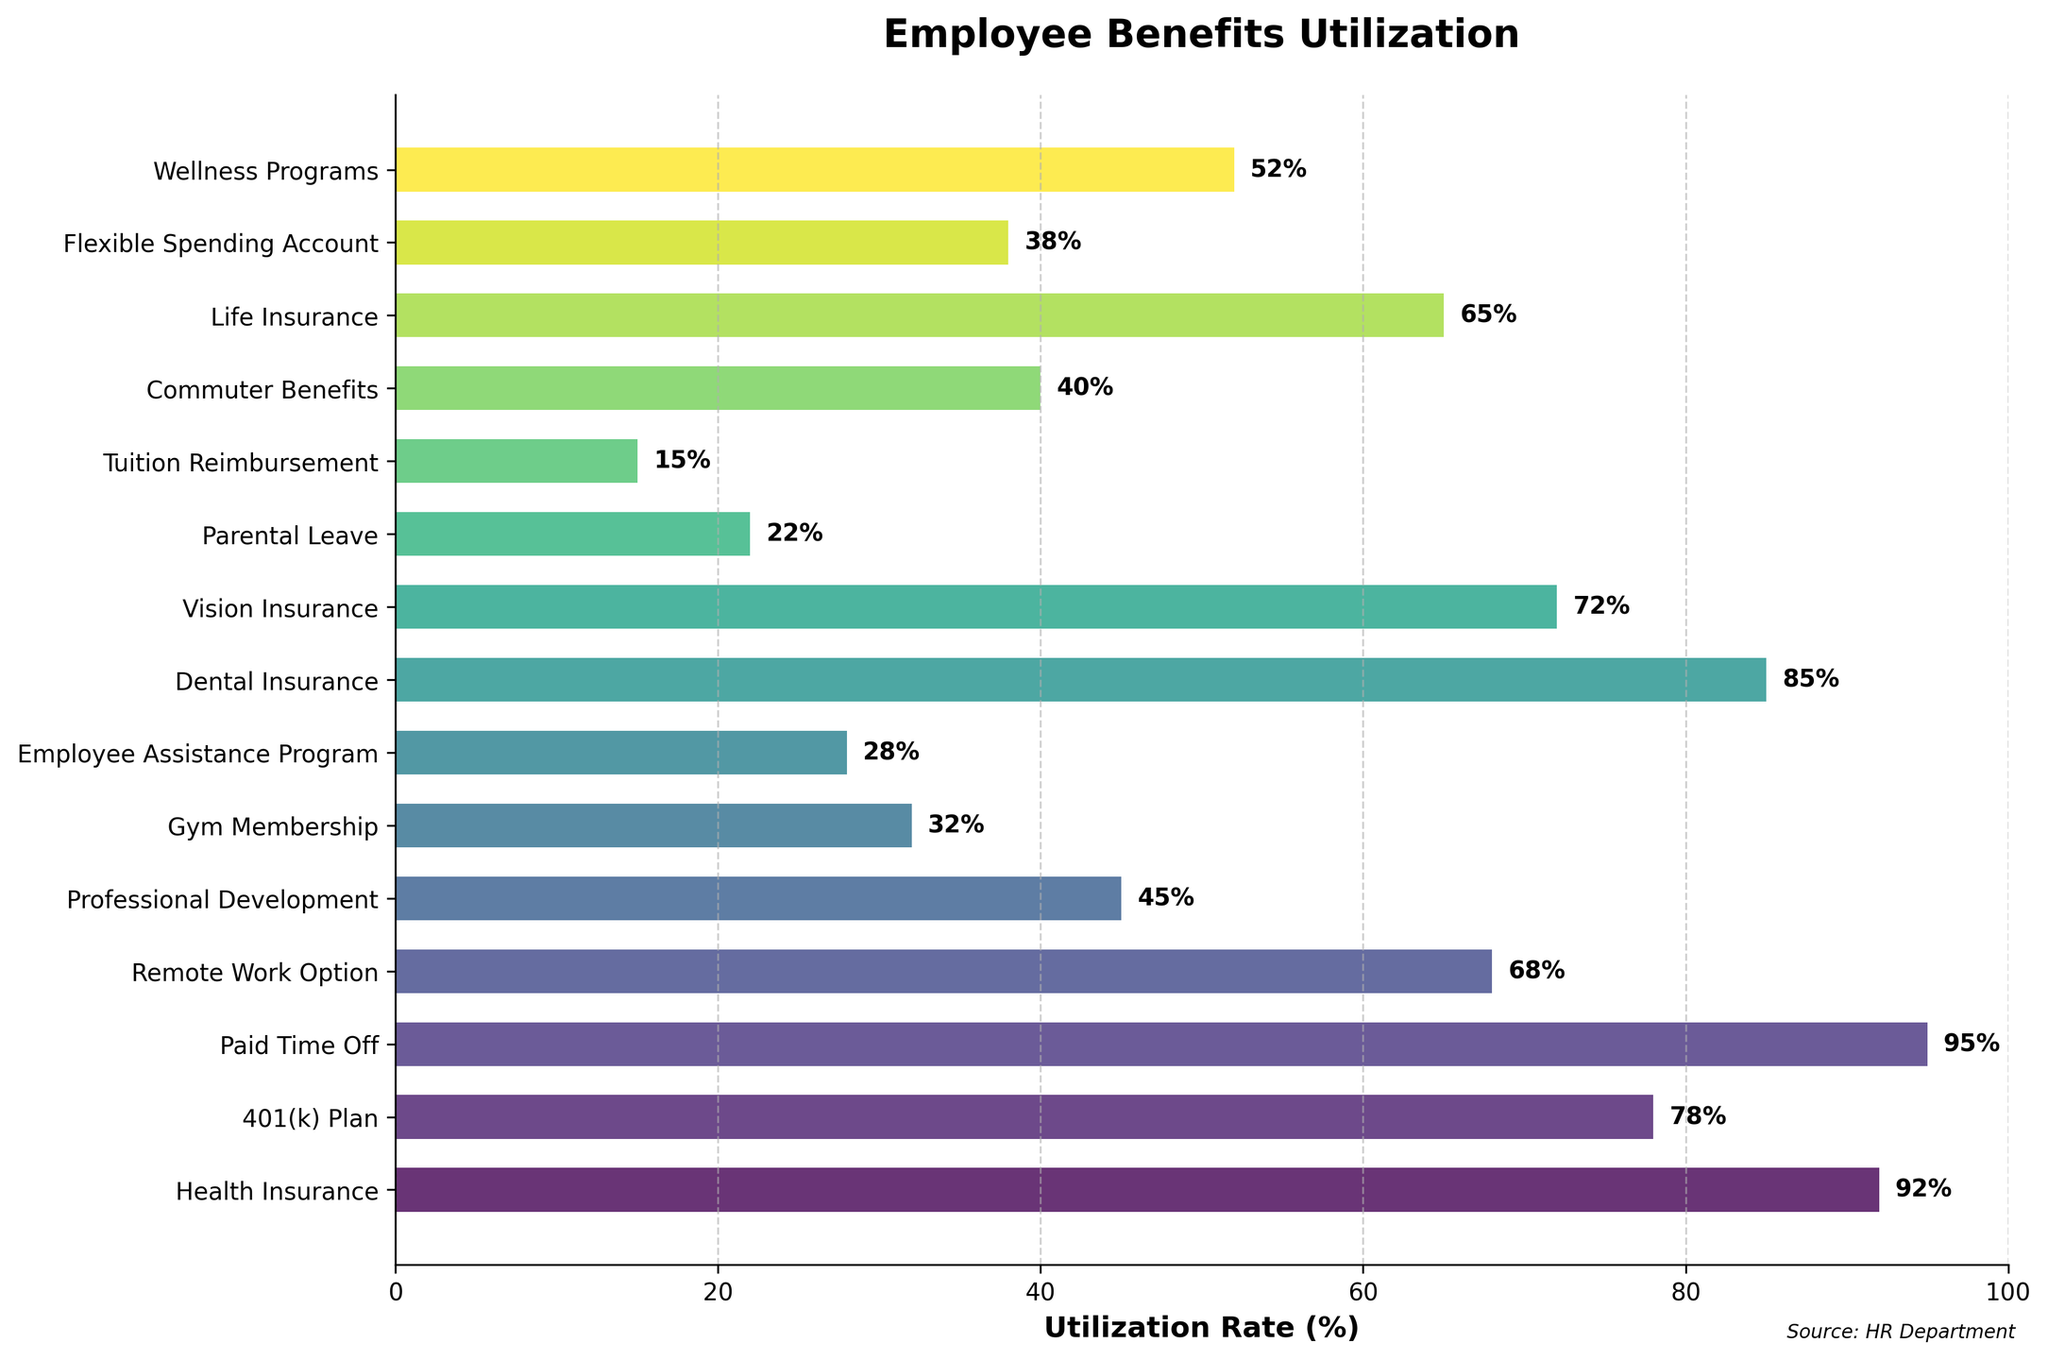Which benefit has the highest utilization rate? Looking at the figure, we can quickly identify the bar with the highest value. "Paid Time Off" has the highest utilization rate of 95% because it reaches the farthest on the x-axis.
Answer: Paid Time Off Which benefit has the lowest utilization rate? By identifying the bar that is the shortest, we can find the lowest utilization rate. "Tuition Reimbursement" has the lowest utilization rate of 15%.
Answer: Tuition Reimbursement What is the average utilization rate of Health Insurance, Dental Insurance, and Vision Insurance? First, find the values: Health Insurance (92%), Dental Insurance (85%), and Vision Insurance (72%). Add them up (92 + 85 + 72 = 249) and then divide by 3 to get the average: 249 / 3 = 83%.
Answer: 83% How much higher is the utilization rate of 401(k) Plan compared to Professional Development? Locate the values for 401(k) Plan (78%) and Professional Development (45%). Subtract the latter from the former (78 - 45 = 33%) to find the difference.
Answer: 33% Rank the following benefits by utilization rate from highest to lowest: Gym Membership, Employee Assistance Program, Commuter Benefits, Remote Work Option. Look at the bars and list the utilization rates: Remote Work Option (68%), Commuter Benefits (40%), Gym Membership (32%), and Employee Assistance Program (28%).
Answer: Remote Work Option, Commuter Benefits, Gym Membership, Employee Assistance Program What is the combined utilization rate of Remote Work Option, Parental Leave, and Life Insurance? Find each value: Remote Work Option (68%), Parental Leave (22%), and Life Insurance (65%). Add them up (68 + 22 + 65 = 155).
Answer: 155% Which benefit has a utilization rate closest to the median utilization rate observed among all benefits? Arrange the utilization rates in ascending order and find the median: 15, 22, 28, 32, 38, 40, 45, 52, 65, 68, 72, 78, 85, 92, 95. The median is the 8th value: Wellness Programs with 52%. Check visually for the bar closest to 52% utilization rate.
Answer: Wellness Programs How much higher is the utilization rate of Health Insurance compared to Gym Membership? Look for the values of Health Insurance (92%) and Gym Membership (32%). Subtract the latter from the former (92 - 32 = 60%) to get the difference.
Answer: 60% Is the utilization rate of Wellness Programs higher or lower than the average utilization rate of the benefits? Calculate the total utilization rate by summing all the individual rates and then divide by the number of benefits. Sum = 878%, number of benefits = 15. Average rate = 878 / 15 = 58.53%. Compare it with Wellness Programs (52%).
Answer: Lower Which benefit around the mid-range (from 40% to 60%) has the highest utilization rate? Identify the bars falling within 40% to 60%: Professional Development (45%), Commuter Benefits (40%), Flexible Spending Account (38%), and Wellness Programs (52%). The highest among these is Wellness Programs.
Answer: Wellness Programs 